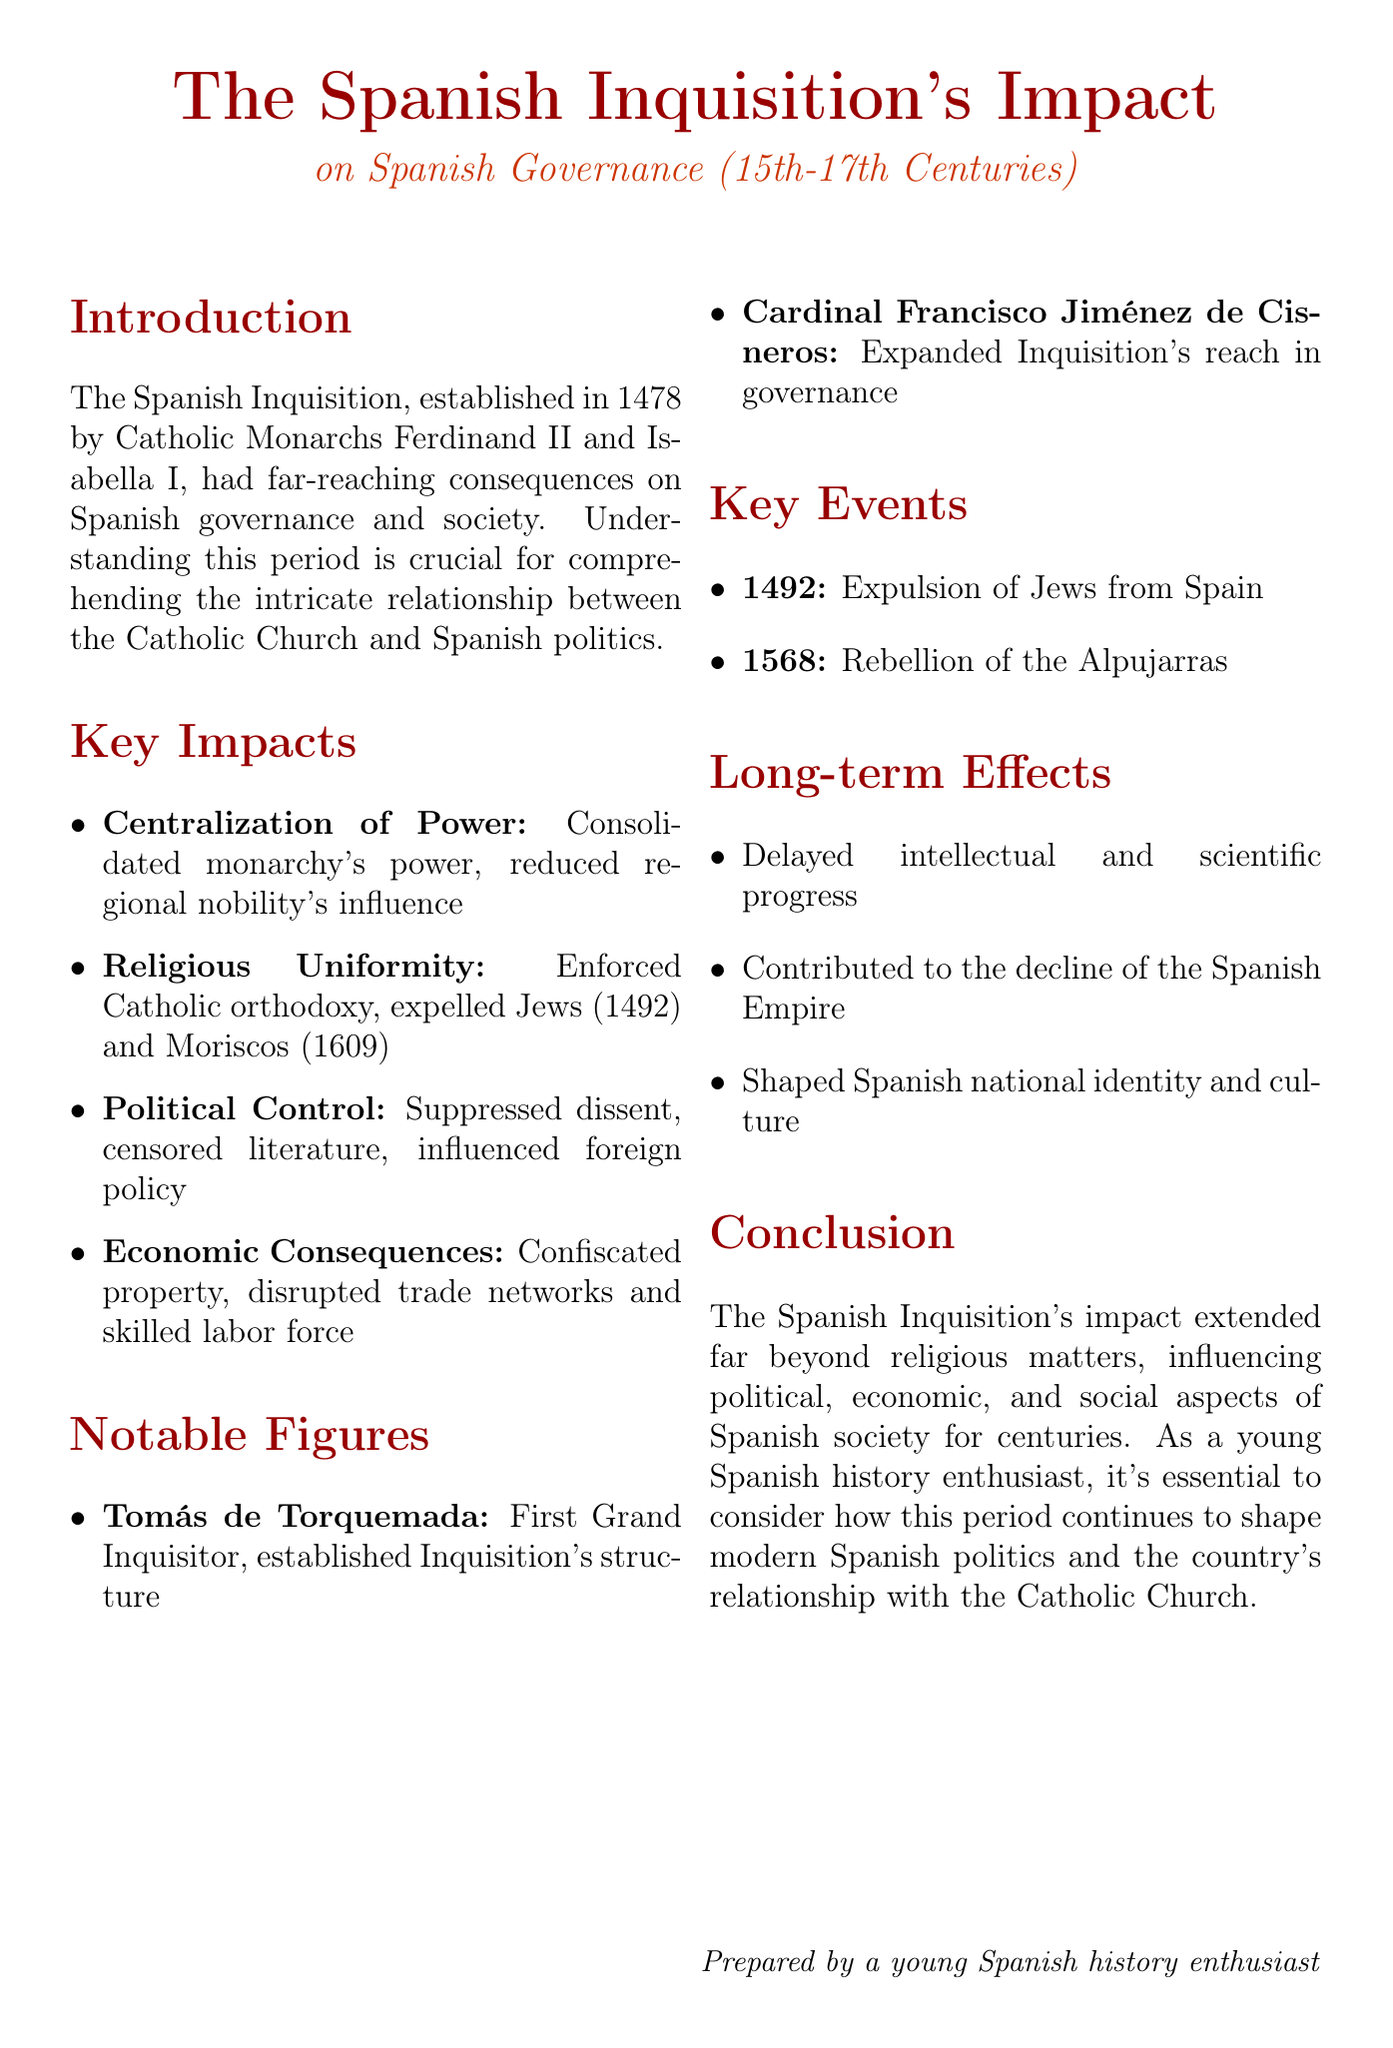What years did the Spanish Inquisition take place? The document highlights the Spanish Inquisition's impact during the 15th-17th centuries, specifically mentioning it was established in 1478 and had notable events up to 1609.
Answer: 15th-17th centuries Who were the Catholic Monarchs that established the Spanish Inquisition? The introduction identifies Ferdinand II and Isabella I as the Catholic Monarchs who established the Spanish Inquisition in 1478.
Answer: Ferdinand II and Isabella I What event occurred in 1492? The document notes the expulsion of Jews from Spain in 1492, marking a significant historical event.
Answer: Expulsion of Jews Who was the First Grand Inquisitor of Spain? Tomás de Torquemada is named in the notable figures section as the First Grand Inquisitor and is significant for establishing the organizational structure of the Inquisition.
Answer: Tomás de Torquemada How did the Inquisition affect regional nobility? The key points section mentions that the Inquisition reduced the influence of regional nobility and local authorities, emphasizing its centralizing role.
Answer: Reduced influence What was one long-term effect of the Spanish Inquisition? The document outlines that the Inquisition delayed intellectual and scientific progress in Spain, indicating a significant long-term impact.
Answer: Delayed progress What does the document state about the Inquisition's impact on Spanish foreign policy? The political control section reveals that the Inquisition influenced Spanish foreign policy, particularly towards Protestant nations, highlighting its broader implications.
Answer: Influenced foreign policy What significant rebellion is mentioned in the document? The document highlights the Rebellion of the Alpujarras in 1568 as an important event indicating tensions in Spanish society.
Answer: Rebellion of the Alpujarras What was one method used by the Inquisition to control power? The document states that the Inquisition was used to suppress political dissent, showcasing a method of exerting control over the populace.
Answer: Suppress political dissent 